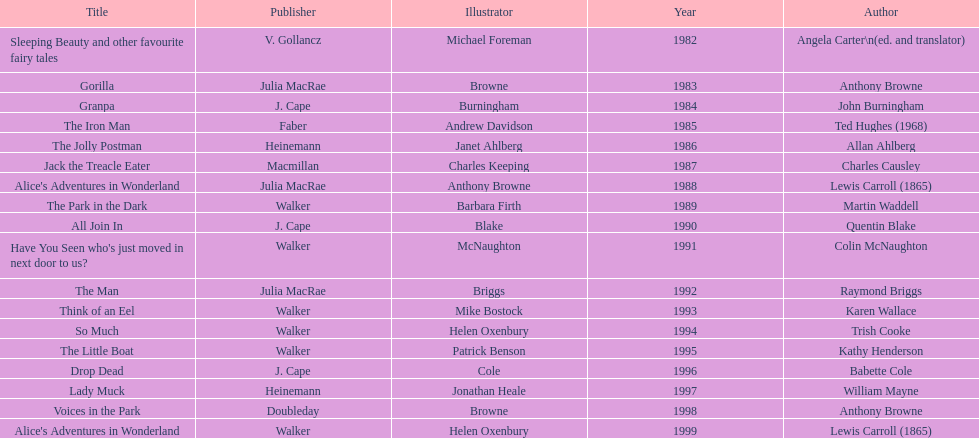Between angela carter's and anthony browne's titles, what is the gap in years of publication? 1. 